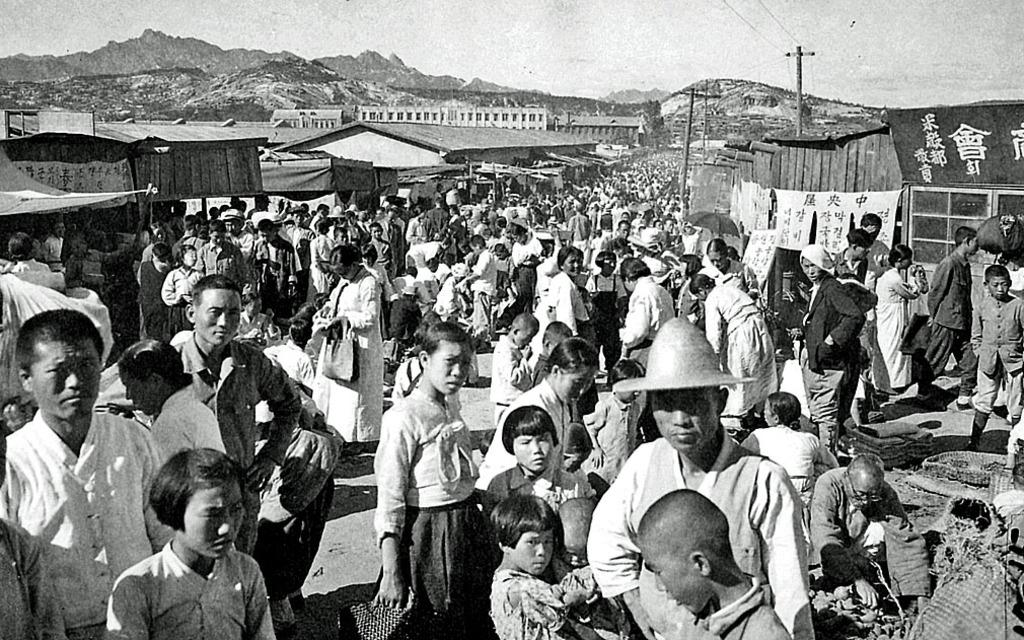What is the color scheme of the image? The image is black and white. What type of landscape can be seen in the image? There are hills in the image. What part of the sky is visible in the image? The sky is visible in the image. What type of infrastructure is present in the image? There are electric poles and electric cables in the image. What type of structures are present in the image? There are buildings, sheds, and tents in the image. What are the people in the image doing? Persons are standing on the ground in the image. How many pins are holding the tent in place in the image? There are no pins visible in the image; the tents are likely secured by other means, such as stakes or ropes. 